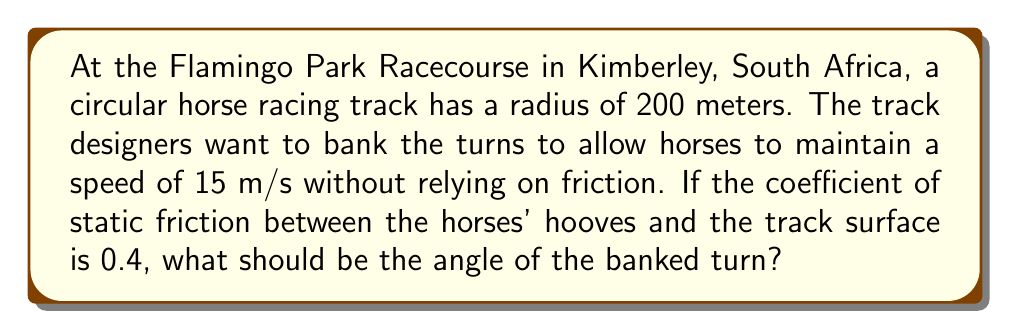Help me with this question. To solve this problem, we'll use the principles of circular motion and the concept of banked turns. Here's a step-by-step approach:

1) In a properly banked turn, the normal force provides the centripetal force needed for circular motion. The equation for this is:

   $$N \sin \theta = \frac{mv^2}{r}$$

   where $N$ is the normal force, $\theta$ is the angle of the bank, $m$ is the mass, $v$ is the velocity, and $r$ is the radius of the turn.

2) The normal force also balances the component of the weight perpendicular to the banked surface:

   $$N \cos \theta = mg$$

   where $g$ is the acceleration due to gravity (9.8 m/s²).

3) Dividing the first equation by the second eliminates $N$:

   $$\frac{\sin \theta}{\cos \theta} = \frac{v^2}{rg}$$

4) This can be simplified to:

   $$\tan \theta = \frac{v^2}{rg}$$

5) Now we can plug in our known values:
   $v = 15$ m/s
   $r = 200$ m
   $g = 9.8$ m/s²

   $$\tan \theta = \frac{15^2}{200 \times 9.8} = 0.1148$$

6) To find $\theta$, we take the inverse tangent (arctan) of both sides:

   $$\theta = \arctan(0.1148) = 6.55°$$

7) To check if this angle is sufficient to prevent slipping, we can compare it to the angle needed if there were no banking:

   $$\tan \theta_{min} = \frac{v^2}{rg} - \mu$$

   where $\mu$ is the coefficient of static friction.

8) Plugging in our values:

   $$\tan \theta_{min} = 0.1148 - 0.4 = -0.2852$$

   $$\theta_{min} = \arctan(-0.2852) = -15.91°$$

Since our calculated angle (6.55°) is greater than this minimum (-15.91°), the banking is sufficient to prevent slipping.
Answer: The angle of the banked turn should be approximately 6.55°. 